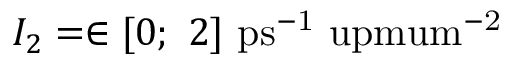Convert formula to latex. <formula><loc_0><loc_0><loc_500><loc_500>I _ { 2 } = \in [ 0 ; 2 ] p s ^ { - 1 } \ u p m u m ^ { - 2 }</formula> 